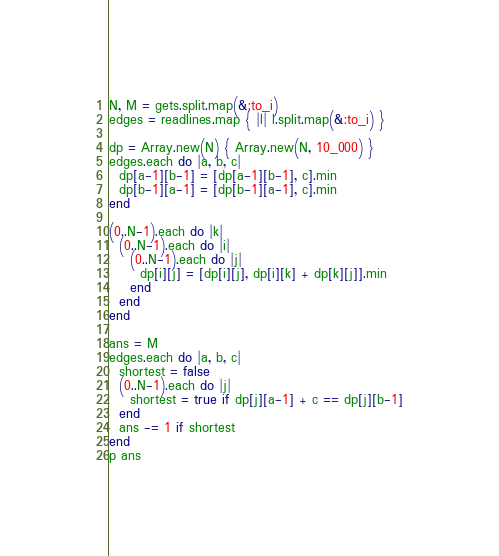Convert code to text. <code><loc_0><loc_0><loc_500><loc_500><_Ruby_>N, M = gets.split.map(&:to_i)
edges = readlines.map { |l| l.split.map(&:to_i) }

dp = Array.new(N) { Array.new(N, 10_000) }
edges.each do |a, b, c|
  dp[a-1][b-1] = [dp[a-1][b-1], c].min
  dp[b-1][a-1] = [dp[b-1][a-1], c].min
end

(0..N-1).each do |k|
  (0..N-1).each do |i|
    (0..N-1).each do |j|
      dp[i][j] = [dp[i][j], dp[i][k] + dp[k][j]].min
    end
  end
end

ans = M
edges.each do |a, b, c|
  shortest = false
  (0..N-1).each do |j|
    shortest = true if dp[j][a-1] + c == dp[j][b-1]
  end
  ans -= 1 if shortest
end
p ans</code> 